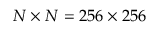<formula> <loc_0><loc_0><loc_500><loc_500>N \times N = 2 5 6 \times 2 5 6</formula> 